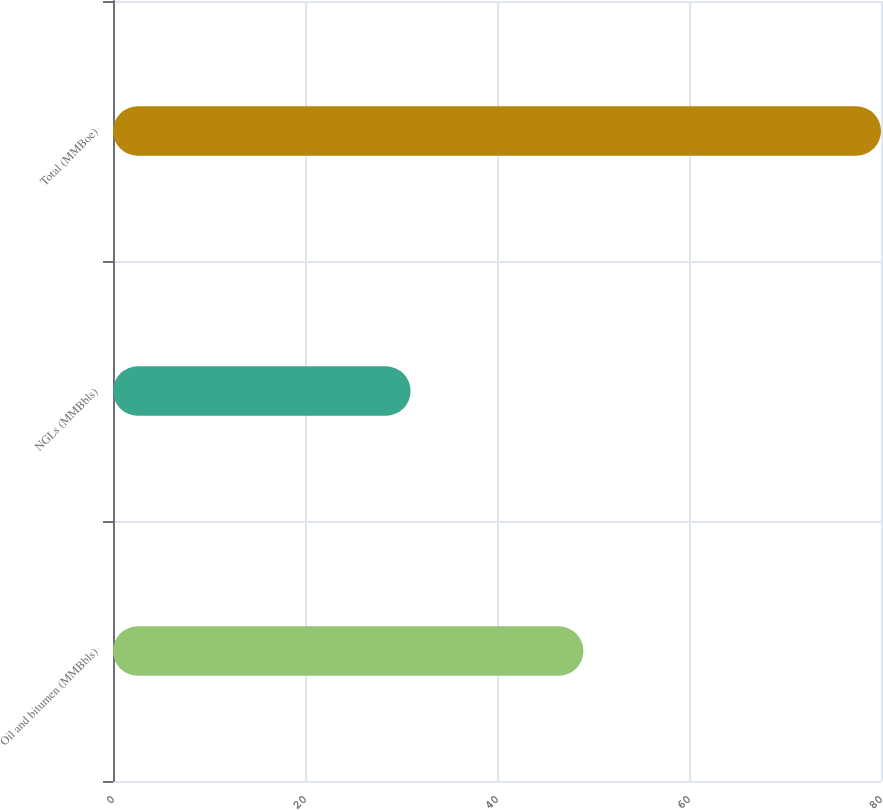Convert chart to OTSL. <chart><loc_0><loc_0><loc_500><loc_500><bar_chart><fcel>Oil and bitumen (MMBbls)<fcel>NGLs (MMBbls)<fcel>Total (MMBoe)<nl><fcel>49<fcel>31<fcel>80<nl></chart> 